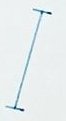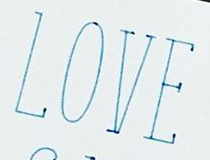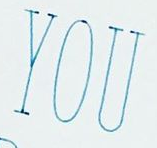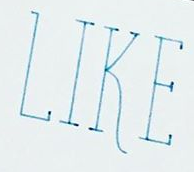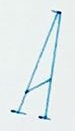What words are shown in these images in order, separated by a semicolon? I; LOVE; YOU; LIKE; A 